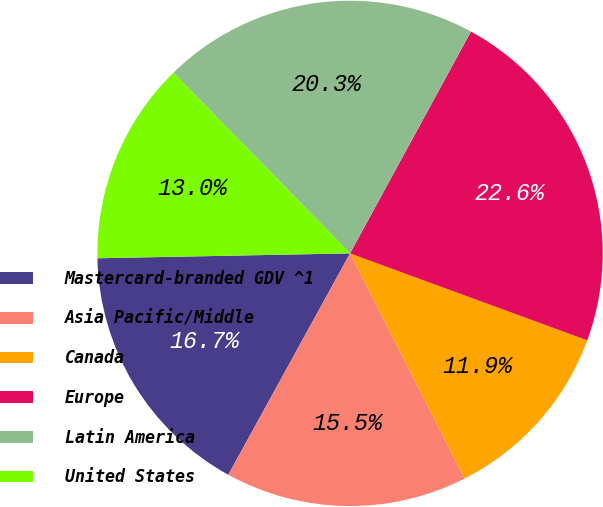Convert chart. <chart><loc_0><loc_0><loc_500><loc_500><pie_chart><fcel>Mastercard-branded GDV ^1<fcel>Asia Pacific/Middle<fcel>Canada<fcel>Europe<fcel>Latin America<fcel>United States<nl><fcel>16.69%<fcel>15.49%<fcel>11.92%<fcel>22.65%<fcel>20.26%<fcel>12.99%<nl></chart> 